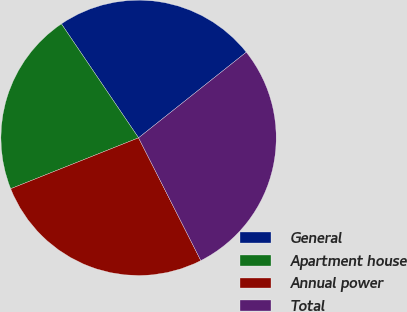<chart> <loc_0><loc_0><loc_500><loc_500><pie_chart><fcel>General<fcel>Apartment house<fcel>Annual power<fcel>Total<nl><fcel>23.78%<fcel>21.56%<fcel>26.44%<fcel>28.22%<nl></chart> 